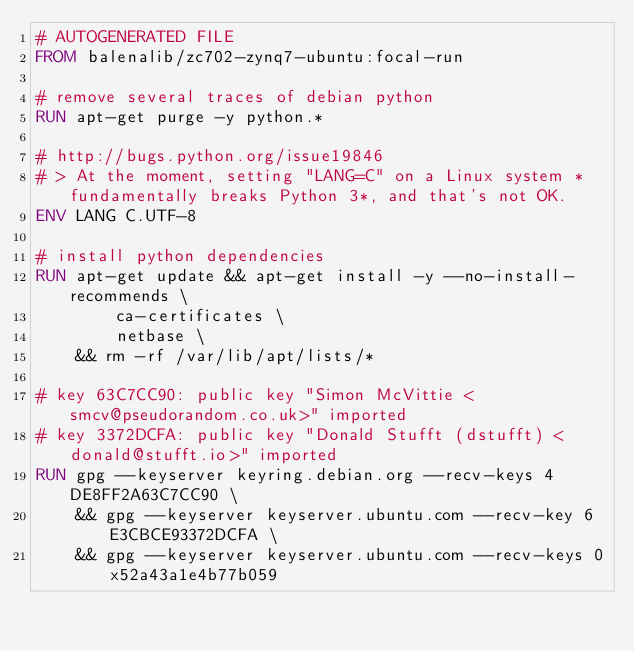<code> <loc_0><loc_0><loc_500><loc_500><_Dockerfile_># AUTOGENERATED FILE
FROM balenalib/zc702-zynq7-ubuntu:focal-run

# remove several traces of debian python
RUN apt-get purge -y python.*

# http://bugs.python.org/issue19846
# > At the moment, setting "LANG=C" on a Linux system *fundamentally breaks Python 3*, and that's not OK.
ENV LANG C.UTF-8

# install python dependencies
RUN apt-get update && apt-get install -y --no-install-recommends \
		ca-certificates \
		netbase \
	&& rm -rf /var/lib/apt/lists/*

# key 63C7CC90: public key "Simon McVittie <smcv@pseudorandom.co.uk>" imported
# key 3372DCFA: public key "Donald Stufft (dstufft) <donald@stufft.io>" imported
RUN gpg --keyserver keyring.debian.org --recv-keys 4DE8FF2A63C7CC90 \
	&& gpg --keyserver keyserver.ubuntu.com --recv-key 6E3CBCE93372DCFA \
	&& gpg --keyserver keyserver.ubuntu.com --recv-keys 0x52a43a1e4b77b059
</code> 